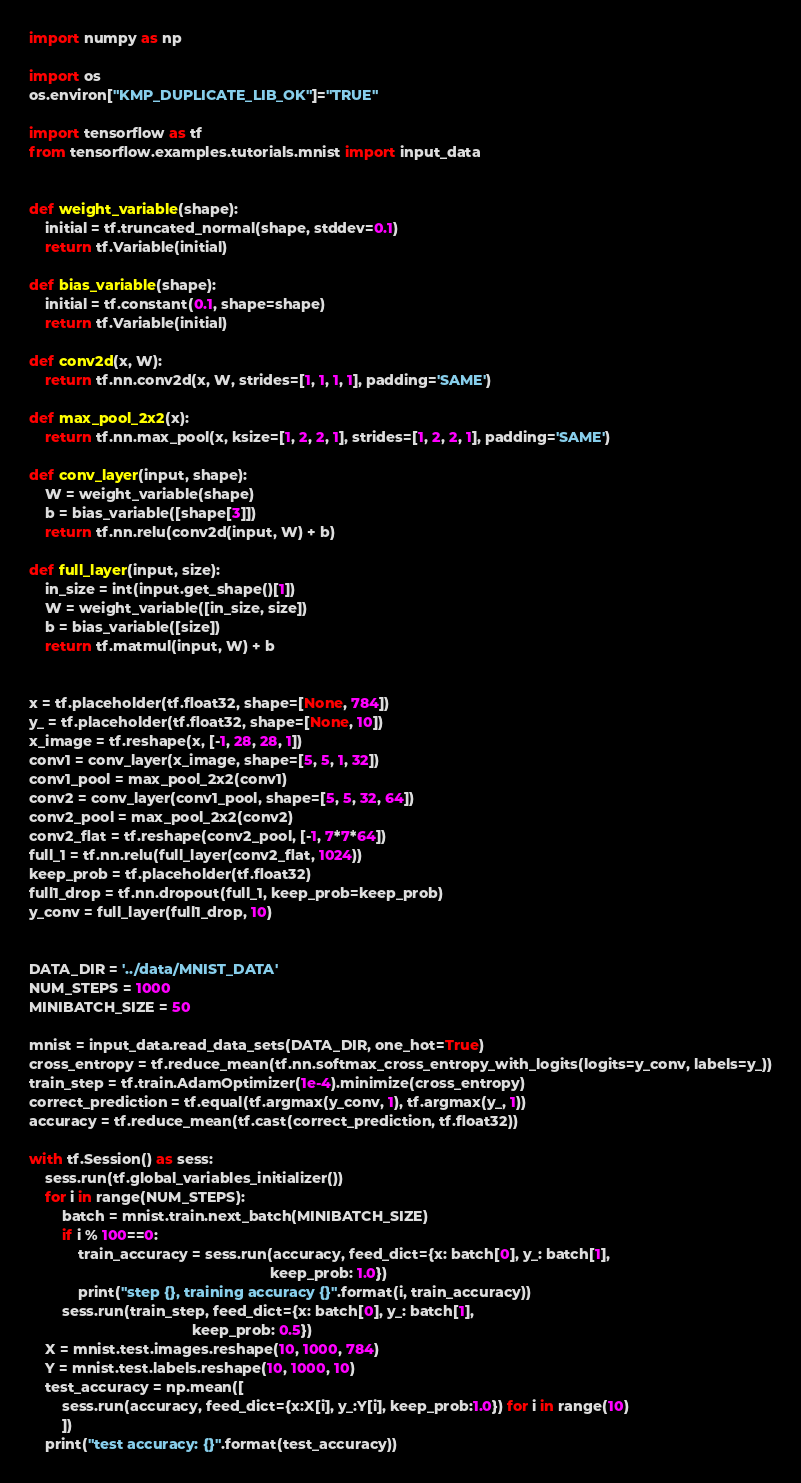<code> <loc_0><loc_0><loc_500><loc_500><_Python_>import numpy as np

import os
os.environ["KMP_DUPLICATE_LIB_OK"]="TRUE"

import tensorflow as tf
from tensorflow.examples.tutorials.mnist import input_data


def weight_variable(shape):
    initial = tf.truncated_normal(shape, stddev=0.1)
    return tf.Variable(initial)

def bias_variable(shape):
    initial = tf.constant(0.1, shape=shape)
    return tf.Variable(initial)

def conv2d(x, W):
    return tf.nn.conv2d(x, W, strides=[1, 1, 1, 1], padding='SAME')

def max_pool_2x2(x):
    return tf.nn.max_pool(x, ksize=[1, 2, 2, 1], strides=[1, 2, 2, 1], padding='SAME')

def conv_layer(input, shape):
    W = weight_variable(shape)
    b = bias_variable([shape[3]])
    return tf.nn.relu(conv2d(input, W) + b)

def full_layer(input, size):
    in_size = int(input.get_shape()[1])
    W = weight_variable([in_size, size])
    b = bias_variable([size])
    return tf.matmul(input, W) + b


x = tf.placeholder(tf.float32, shape=[None, 784])
y_ = tf.placeholder(tf.float32, shape=[None, 10])
x_image = tf.reshape(x, [-1, 28, 28, 1])
conv1 = conv_layer(x_image, shape=[5, 5, 1, 32])
conv1_pool = max_pool_2x2(conv1)
conv2 = conv_layer(conv1_pool, shape=[5, 5, 32, 64])
conv2_pool = max_pool_2x2(conv2)
conv2_flat = tf.reshape(conv2_pool, [-1, 7*7*64])
full_1 = tf.nn.relu(full_layer(conv2_flat, 1024))
keep_prob = tf.placeholder(tf.float32)
full1_drop = tf.nn.dropout(full_1, keep_prob=keep_prob)
y_conv = full_layer(full1_drop, 10)


DATA_DIR = '../data/MNIST_DATA'
NUM_STEPS = 1000
MINIBATCH_SIZE = 50

mnist = input_data.read_data_sets(DATA_DIR, one_hot=True)
cross_entropy = tf.reduce_mean(tf.nn.softmax_cross_entropy_with_logits(logits=y_conv, labels=y_))
train_step = tf.train.AdamOptimizer(1e-4).minimize(cross_entropy)
correct_prediction = tf.equal(tf.argmax(y_conv, 1), tf.argmax(y_, 1))
accuracy = tf.reduce_mean(tf.cast(correct_prediction, tf.float32))

with tf.Session() as sess:
    sess.run(tf.global_variables_initializer())
    for i in range(NUM_STEPS):
        batch = mnist.train.next_batch(MINIBATCH_SIZE)
        if i % 100==0:
            train_accuracy = sess.run(accuracy, feed_dict={x: batch[0], y_: batch[1],
                                                           keep_prob: 1.0})
            print("step {}, training accuracy {}".format(i, train_accuracy))
        sess.run(train_step, feed_dict={x: batch[0], y_: batch[1],
                                        keep_prob: 0.5})
    X = mnist.test.images.reshape(10, 1000, 784)
    Y = mnist.test.labels.reshape(10, 1000, 10)
    test_accuracy = np.mean([
        sess.run(accuracy, feed_dict={x:X[i], y_:Y[i], keep_prob:1.0}) for i in range(10)
        ])
    print("test accuracy: {}".format(test_accuracy))
</code> 